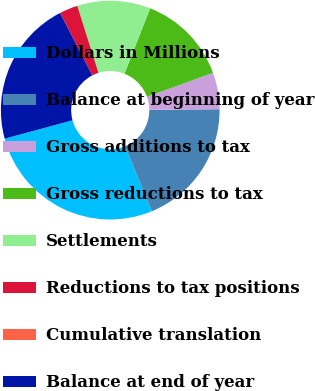Convert chart to OTSL. <chart><loc_0><loc_0><loc_500><loc_500><pie_chart><fcel>Dollars in Millions<fcel>Balance at beginning of year<fcel>Gross additions to tax<fcel>Gross reductions to tax<fcel>Settlements<fcel>Reductions to tax positions<fcel>Cumulative translation<fcel>Balance at end of year<nl><fcel>27.01%<fcel>18.91%<fcel>5.41%<fcel>13.51%<fcel>10.81%<fcel>2.71%<fcel>0.01%<fcel>21.61%<nl></chart> 